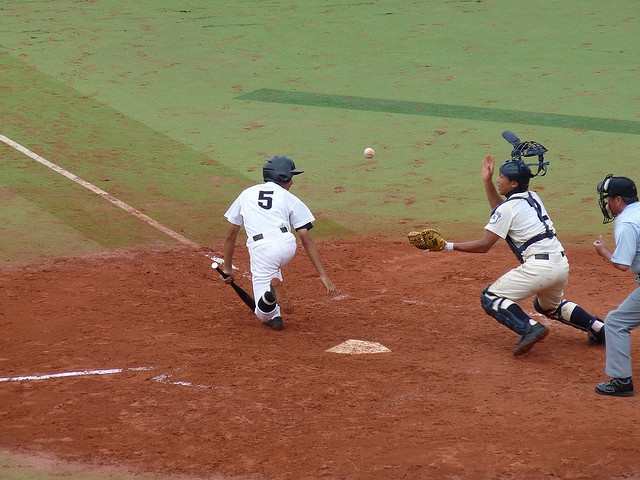Describe the objects in this image and their specific colors. I can see people in olive, lightgray, black, gray, and maroon tones, people in olive, lavender, black, brown, and gray tones, people in olive, black, and gray tones, baseball glove in olive, maroon, and black tones, and baseball bat in olive, black, white, brown, and maroon tones in this image. 